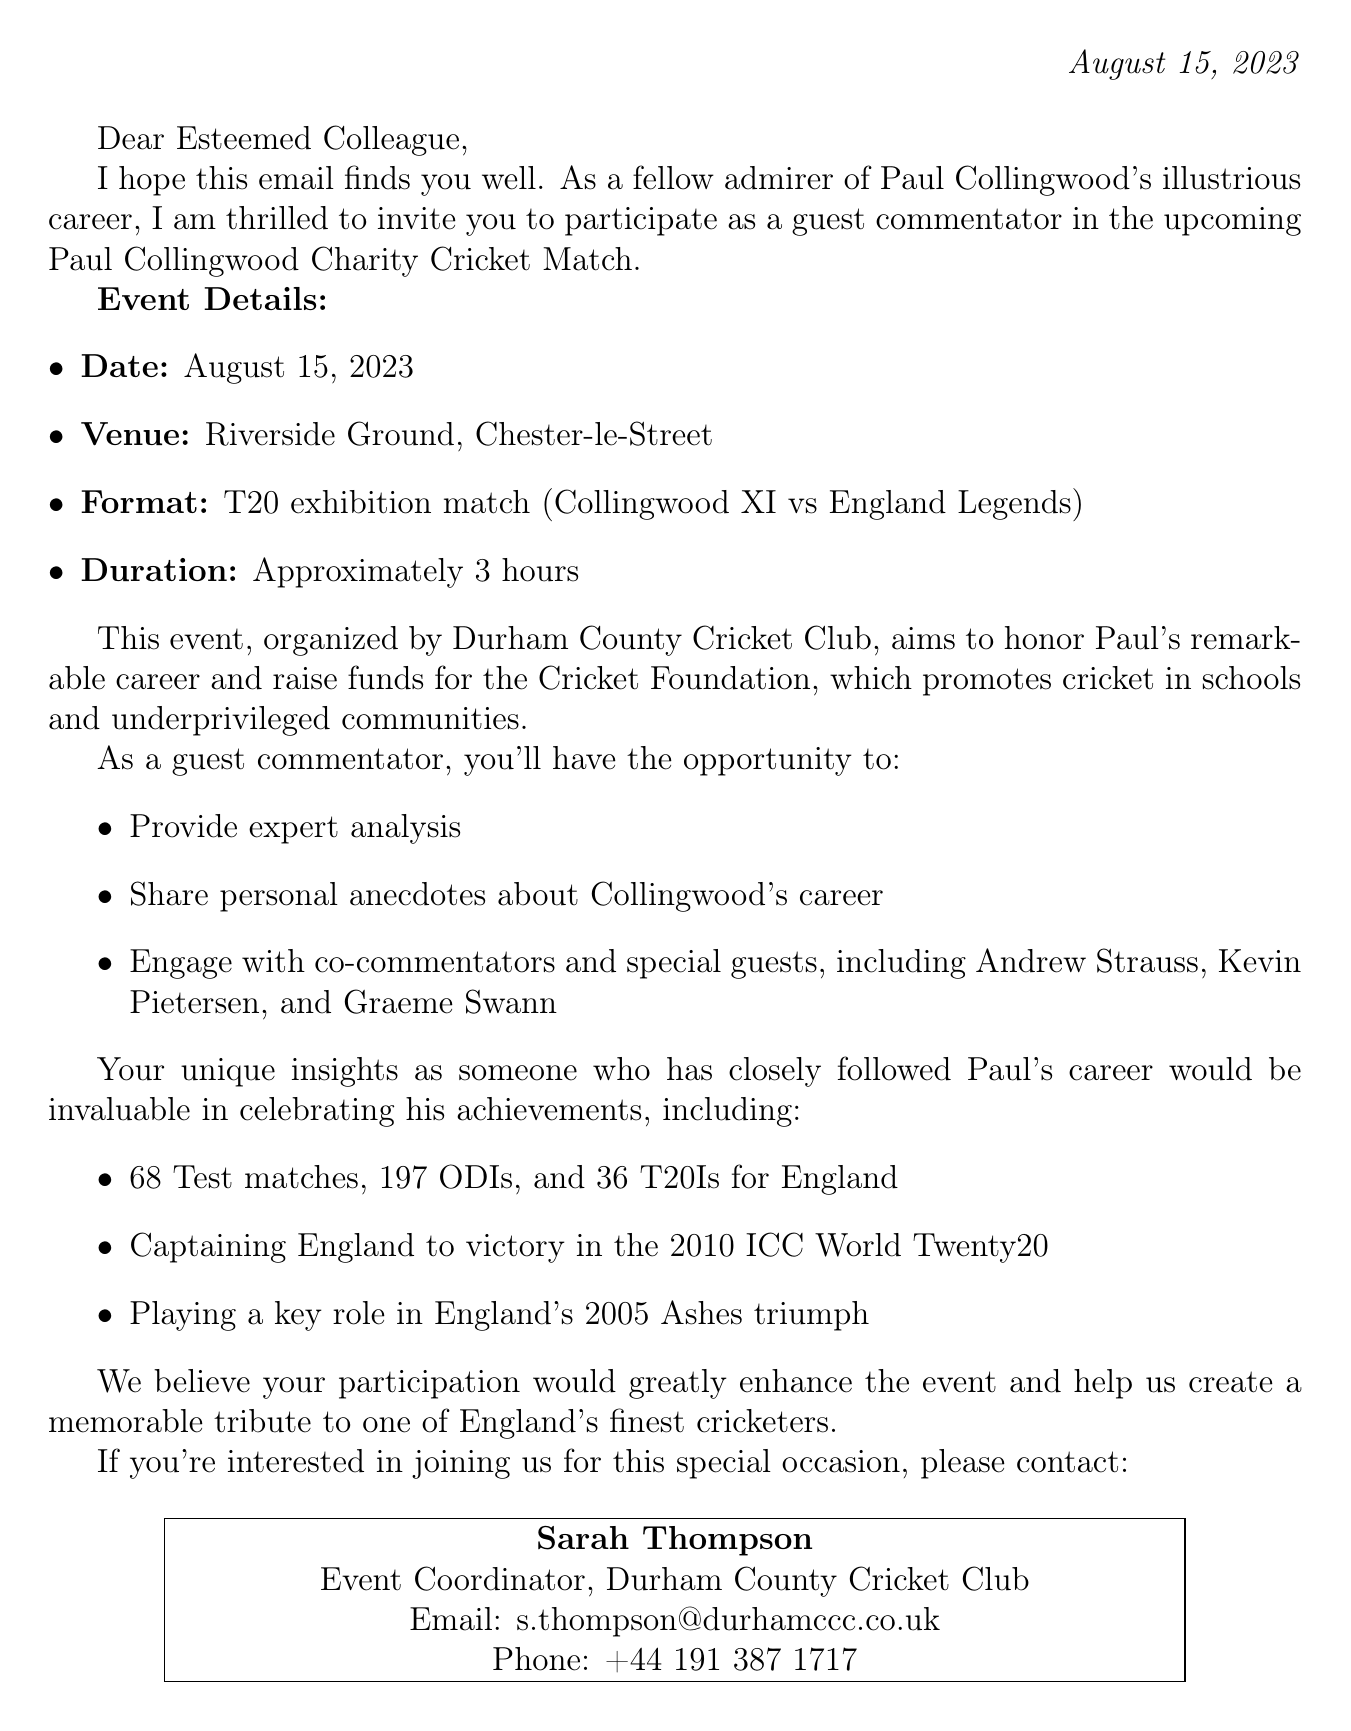What is the date of the charity match? The date of the charity match is mentioned in the document as August 15, 2023.
Answer: August 15, 2023 What is the venue for the match? The venue for the match is specified as Riverside Ground, Chester-le-Street in the event details.
Answer: Riverside Ground, Chester-le-Street Who is the organizer of the event? The document indicates that the organizer of the event is Durham County Cricket Club.
Answer: Durham County Cricket Club What is the match format? The match format given in the document is a T20 exhibition match between Collingwood XI and England Legends.
Answer: T20 exhibition match Who are some of the special guests mentioned? The document lists special guests who will be attending, such as Andrew Strauss, Kevin Pietersen, and Graeme Swann.
Answer: Andrew Strauss, Kevin Pietersen, Graeme Swann What is the purpose of the charity match? The purpose of the charity match is stated as honoring Paul Collingwood's career and raising funds for the Cricket Foundation.
Answer: To honor Paul Collingwood's career and raise funds for the Cricket Foundation How long will the match last? The document specifies that the match will last approximately 3 hours.
Answer: Approximately 3 hours What are the responsibilities of the guest commentator? The responsibilities include providing expert analysis, sharing personal anecdotes about Collingwood, and engaging with co-commentators and special guests.
Answer: Provide expert analysis, share personal anecdotes, engage with co-commentators Who should participants contact for more information? Participants are advised to contact Sarah Thompson for further information regarding the event.
Answer: Sarah Thompson 